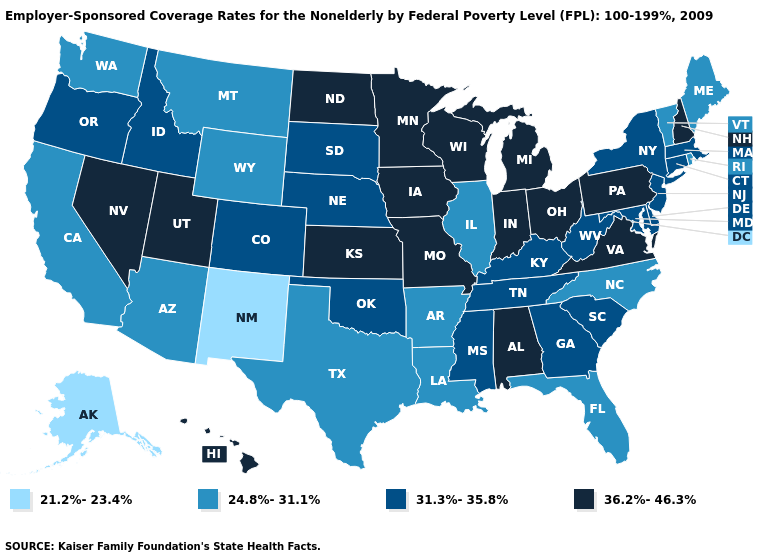Which states have the highest value in the USA?
Give a very brief answer. Alabama, Hawaii, Indiana, Iowa, Kansas, Michigan, Minnesota, Missouri, Nevada, New Hampshire, North Dakota, Ohio, Pennsylvania, Utah, Virginia, Wisconsin. Does Nevada have the lowest value in the USA?
Answer briefly. No. Among the states that border Kentucky , which have the lowest value?
Give a very brief answer. Illinois. How many symbols are there in the legend?
Keep it brief. 4. What is the highest value in states that border New York?
Give a very brief answer. 36.2%-46.3%. What is the value of Florida?
Be succinct. 24.8%-31.1%. Among the states that border Wyoming , does South Dakota have the lowest value?
Keep it brief. No. Does Kansas have a higher value than New Hampshire?
Be succinct. No. What is the value of California?
Quick response, please. 24.8%-31.1%. What is the lowest value in states that border Arizona?
Concise answer only. 21.2%-23.4%. What is the value of Arizona?
Answer briefly. 24.8%-31.1%. Does Hawaii have a higher value than Rhode Island?
Keep it brief. Yes. What is the value of Alaska?
Concise answer only. 21.2%-23.4%. What is the value of New Hampshire?
Concise answer only. 36.2%-46.3%. Which states have the lowest value in the USA?
Concise answer only. Alaska, New Mexico. 